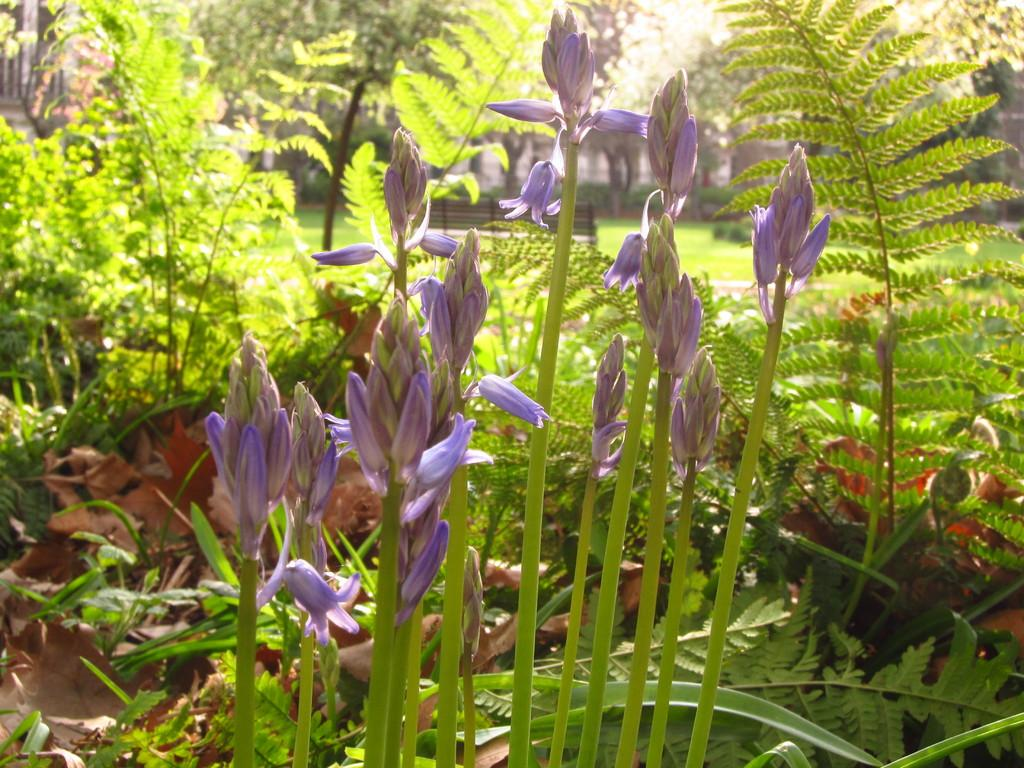What is located in the middle of the image? There are flower plants in the middle of the image. What type of flowers can be seen in the middle of the image? There are lavender-colored flowers in the middle of the image. What can be seen in the background of the image? There is a ground visible in the background of the image. What type of vegetation surrounds the ground in the image? There are trees around the ground. Can you describe the smell of the town in the image? There is no town present in the image, so it is not possible to describe the smell of a town. 